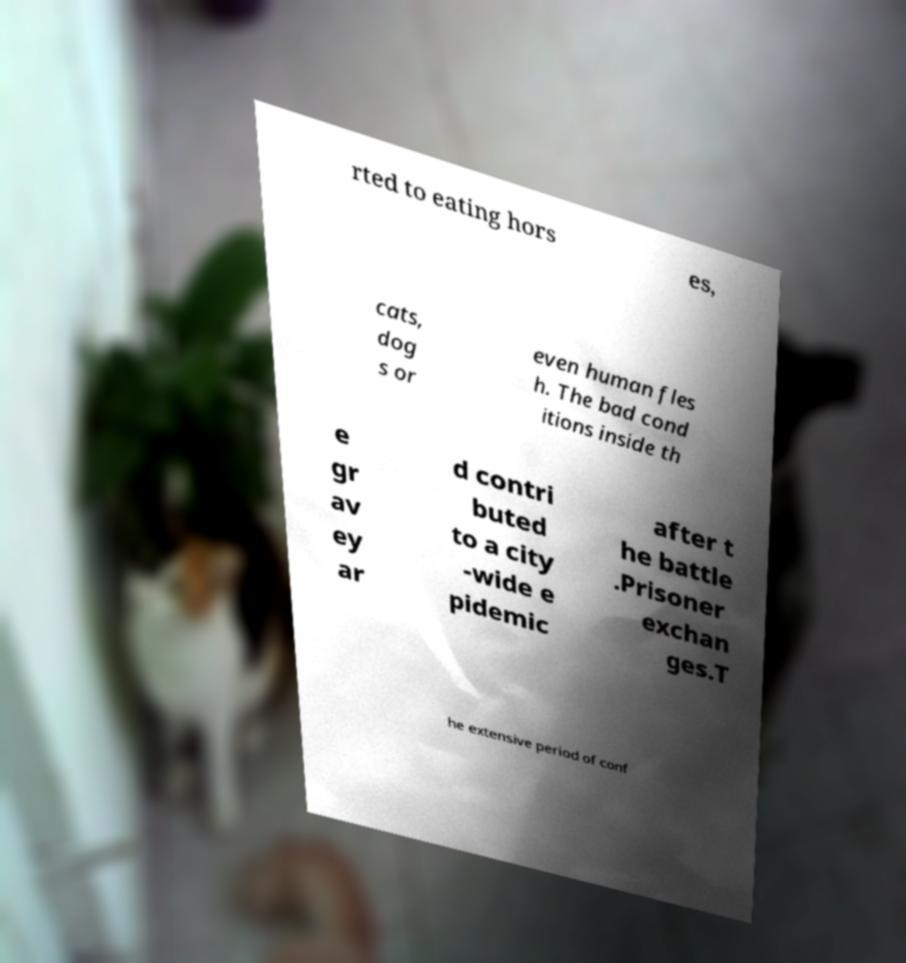What messages or text are displayed in this image? I need them in a readable, typed format. rted to eating hors es, cats, dog s or even human fles h. The bad cond itions inside th e gr av ey ar d contri buted to a city -wide e pidemic after t he battle .Prisoner exchan ges.T he extensive period of conf 